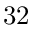Convert formula to latex. <formula><loc_0><loc_0><loc_500><loc_500>3 2</formula> 